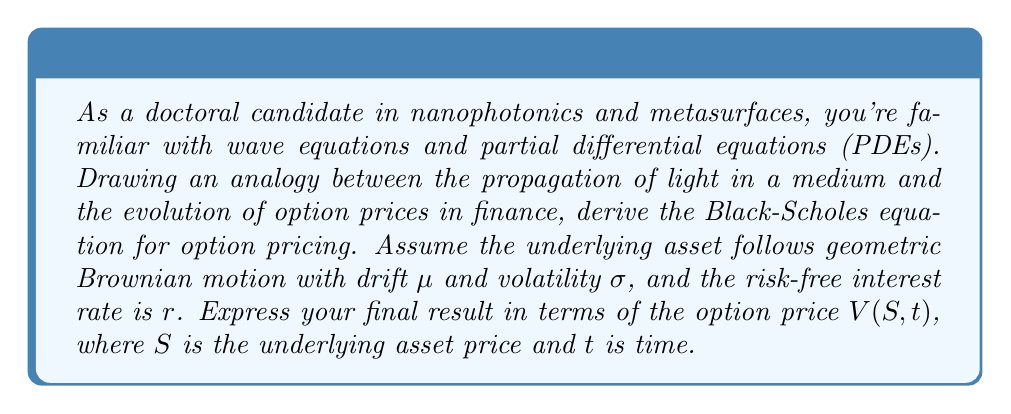Could you help me with this problem? To derive the Black-Scholes equation, we'll follow these steps:

1. Begin with the stochastic differential equation (SDE) for the underlying asset:
   $$dS = \mu S dt + \sigma S dW$$
   where $W$ is a Wiener process.

2. Apply Itô's lemma to the option price $V(S,t)$:
   $$dV = \frac{\partial V}{\partial t}dt + \frac{\partial V}{\partial S}dS + \frac{1}{2}\frac{\partial^2 V}{\partial S^2}(dS)^2$$

3. Substitute the SDE for $dS$ and simplify:
   $$dV = \frac{\partial V}{\partial t}dt + \frac{\partial V}{\partial S}(\mu S dt + \sigma S dW) + \frac{1}{2}\frac{\partial^2 V}{\partial S^2}\sigma^2 S^2 dt$$

4. Construct a risk-free portfolio by holding the option and shorting $\frac{\partial V}{\partial S}$ shares of the underlying asset:
   $$\Pi = V - \frac{\partial V}{\partial S}S$$

5. Calculate the change in the portfolio value:
   $$d\Pi = dV - \frac{\partial V}{\partial S}dS$$

6. Substitute the expressions for $dV$ and $dS$:
   $$d\Pi = \left(\frac{\partial V}{\partial t} + \frac{1}{2}\sigma^2 S^2 \frac{\partial^2 V}{\partial S^2}\right)dt$$

7. Since the portfolio is risk-free, its return should equal the risk-free rate:
   $$d\Pi = r\Pi dt = r\left(V - \frac{\partial V}{\partial S}S\right)dt$$

8. Equate the two expressions for $d\Pi$ and rearrange:
   $$\frac{\partial V}{\partial t} + \frac{1}{2}\sigma^2 S^2 \frac{\partial^2 V}{\partial S^2} + rS\frac{\partial V}{\partial S} - rV = 0$$

This is the Black-Scholes equation, a second-order linear parabolic PDE. The equation describes the evolution of the option price $V(S,t)$ over time, similar to how wave equations in nanophotonics describe the propagation of electromagnetic waves through a medium.
Answer: The Black-Scholes equation for option pricing is:

$$\frac{\partial V}{\partial t} + \frac{1}{2}\sigma^2 S^2 \frac{\partial^2 V}{\partial S^2} + rS\frac{\partial V}{\partial S} - rV = 0$$

where $V(S,t)$ is the option price, $S$ is the underlying asset price, $t$ is time, $\sigma$ is the volatility of the underlying asset, and $r$ is the risk-free interest rate. 